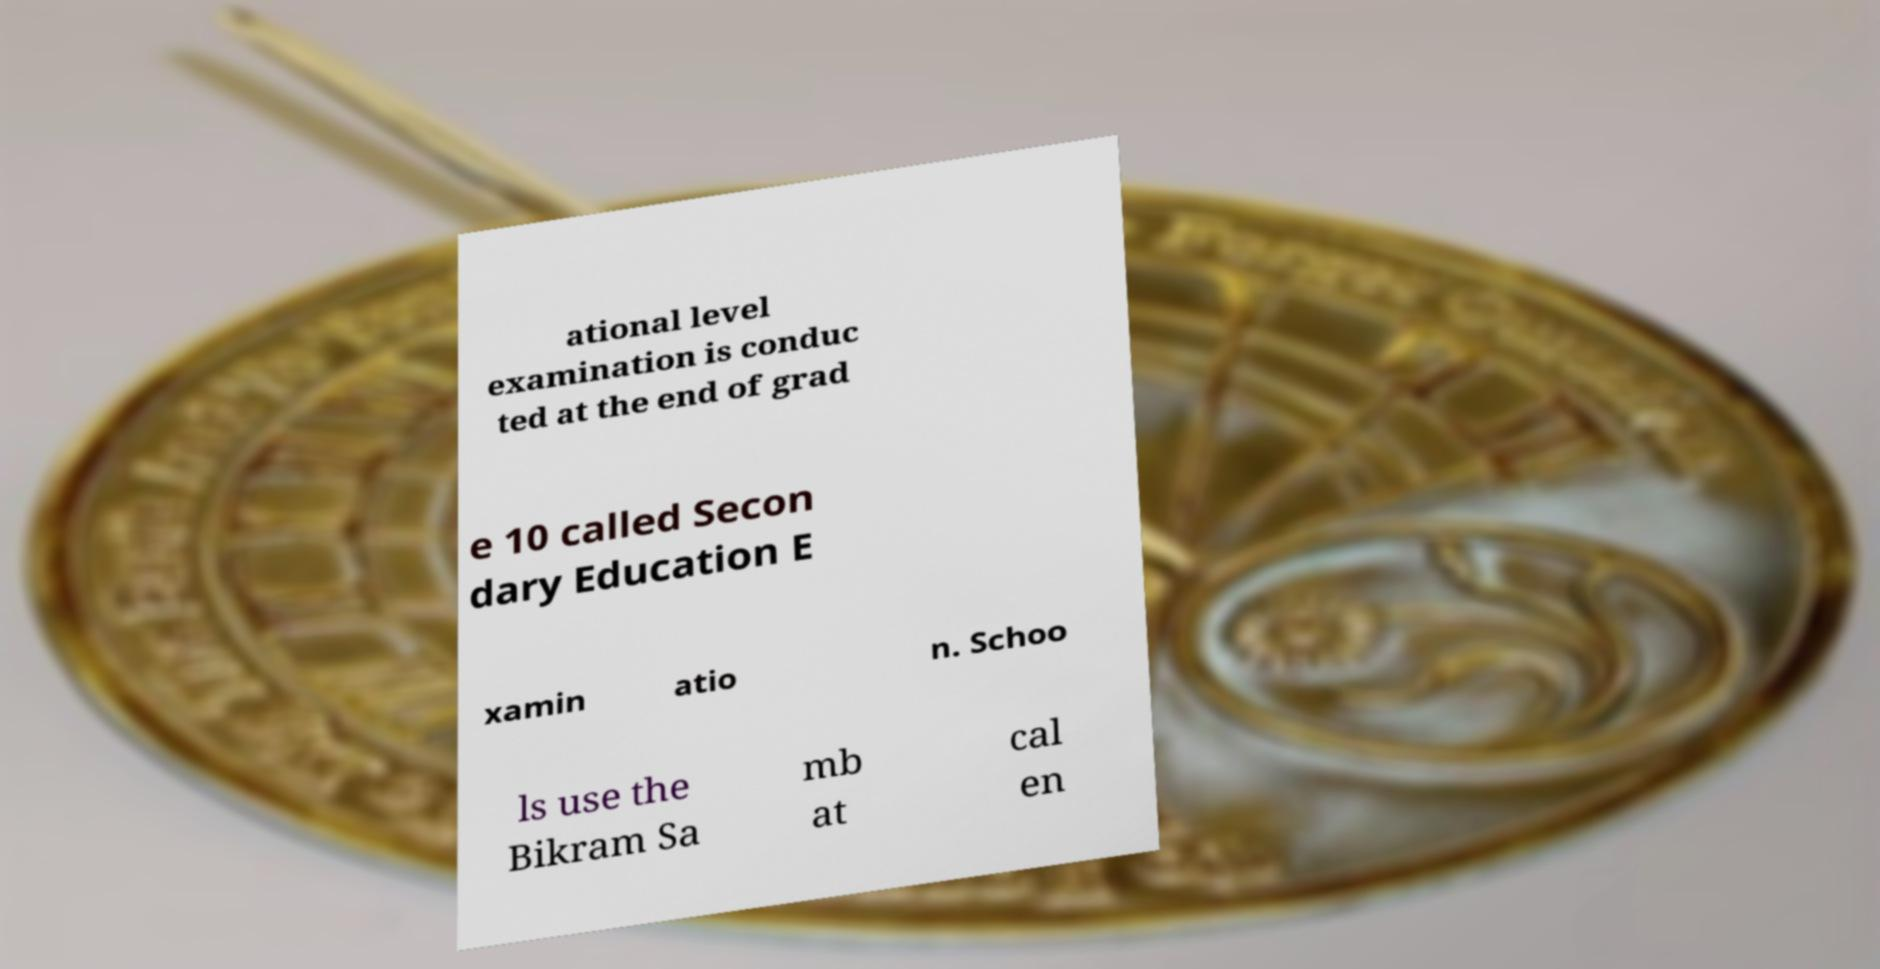There's text embedded in this image that I need extracted. Can you transcribe it verbatim? ational level examination is conduc ted at the end of grad e 10 called Secon dary Education E xamin atio n. Schoo ls use the Bikram Sa mb at cal en 